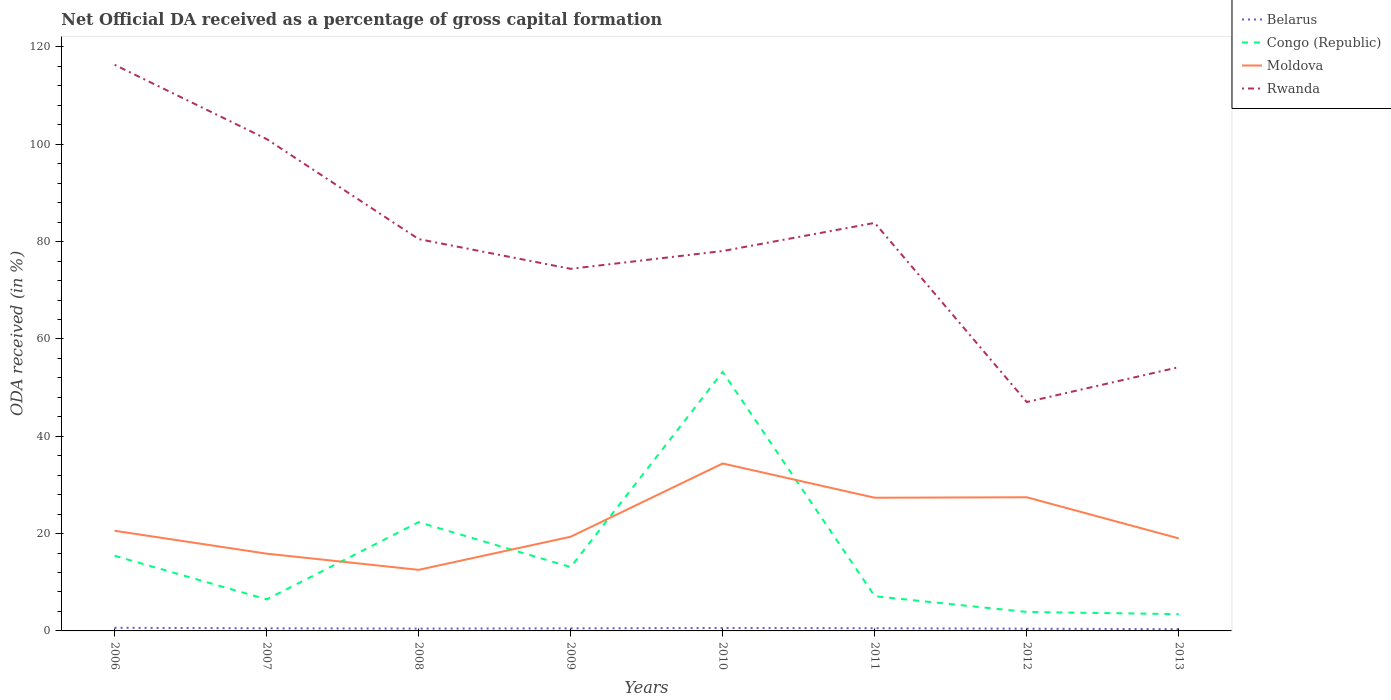How many different coloured lines are there?
Offer a very short reply. 4. Does the line corresponding to Congo (Republic) intersect with the line corresponding to Moldova?
Your answer should be compact. Yes. Across all years, what is the maximum net ODA received in Moldova?
Give a very brief answer. 12.55. In which year was the net ODA received in Congo (Republic) maximum?
Provide a succinct answer. 2013. What is the total net ODA received in Rwanda in the graph?
Ensure brevity in your answer.  38.27. What is the difference between the highest and the second highest net ODA received in Congo (Republic)?
Your response must be concise. 49.77. Is the net ODA received in Moldova strictly greater than the net ODA received in Rwanda over the years?
Your answer should be very brief. Yes. How many lines are there?
Your response must be concise. 4. How many years are there in the graph?
Ensure brevity in your answer.  8. What is the difference between two consecutive major ticks on the Y-axis?
Provide a succinct answer. 20. Does the graph contain grids?
Offer a very short reply. No. What is the title of the graph?
Give a very brief answer. Net Official DA received as a percentage of gross capital formation. What is the label or title of the X-axis?
Make the answer very short. Years. What is the label or title of the Y-axis?
Provide a succinct answer. ODA received (in %). What is the ODA received (in %) in Belarus in 2006?
Keep it short and to the point. 0.64. What is the ODA received (in %) of Congo (Republic) in 2006?
Ensure brevity in your answer.  15.44. What is the ODA received (in %) in Moldova in 2006?
Make the answer very short. 20.58. What is the ODA received (in %) of Rwanda in 2006?
Your answer should be compact. 116.34. What is the ODA received (in %) in Belarus in 2007?
Provide a succinct answer. 0.54. What is the ODA received (in %) of Congo (Republic) in 2007?
Offer a very short reply. 6.48. What is the ODA received (in %) of Moldova in 2007?
Give a very brief answer. 15.88. What is the ODA received (in %) of Rwanda in 2007?
Offer a very short reply. 101.08. What is the ODA received (in %) of Belarus in 2008?
Offer a terse response. 0.48. What is the ODA received (in %) in Congo (Republic) in 2008?
Provide a short and direct response. 22.34. What is the ODA received (in %) in Moldova in 2008?
Provide a succinct answer. 12.55. What is the ODA received (in %) in Rwanda in 2008?
Your answer should be compact. 80.52. What is the ODA received (in %) in Belarus in 2009?
Offer a very short reply. 0.53. What is the ODA received (in %) in Congo (Republic) in 2009?
Your answer should be very brief. 13.12. What is the ODA received (in %) of Moldova in 2009?
Offer a terse response. 19.36. What is the ODA received (in %) of Rwanda in 2009?
Provide a short and direct response. 74.41. What is the ODA received (in %) in Belarus in 2010?
Ensure brevity in your answer.  0.61. What is the ODA received (in %) of Congo (Republic) in 2010?
Your answer should be very brief. 53.22. What is the ODA received (in %) of Moldova in 2010?
Provide a short and direct response. 34.41. What is the ODA received (in %) of Rwanda in 2010?
Give a very brief answer. 78.07. What is the ODA received (in %) in Belarus in 2011?
Offer a very short reply. 0.56. What is the ODA received (in %) in Congo (Republic) in 2011?
Offer a very short reply. 7.13. What is the ODA received (in %) of Moldova in 2011?
Your response must be concise. 27.37. What is the ODA received (in %) in Rwanda in 2011?
Give a very brief answer. 83.84. What is the ODA received (in %) of Belarus in 2012?
Your response must be concise. 0.46. What is the ODA received (in %) in Congo (Republic) in 2012?
Your response must be concise. 3.9. What is the ODA received (in %) in Moldova in 2012?
Offer a very short reply. 27.47. What is the ODA received (in %) in Rwanda in 2012?
Provide a short and direct response. 47.03. What is the ODA received (in %) in Belarus in 2013?
Provide a succinct answer. 0.36. What is the ODA received (in %) in Congo (Republic) in 2013?
Offer a very short reply. 3.45. What is the ODA received (in %) in Moldova in 2013?
Give a very brief answer. 19.02. What is the ODA received (in %) of Rwanda in 2013?
Offer a very short reply. 54.19. Across all years, what is the maximum ODA received (in %) in Belarus?
Ensure brevity in your answer.  0.64. Across all years, what is the maximum ODA received (in %) of Congo (Republic)?
Give a very brief answer. 53.22. Across all years, what is the maximum ODA received (in %) in Moldova?
Offer a terse response. 34.41. Across all years, what is the maximum ODA received (in %) in Rwanda?
Offer a very short reply. 116.34. Across all years, what is the minimum ODA received (in %) in Belarus?
Provide a succinct answer. 0.36. Across all years, what is the minimum ODA received (in %) of Congo (Republic)?
Ensure brevity in your answer.  3.45. Across all years, what is the minimum ODA received (in %) of Moldova?
Offer a terse response. 12.55. Across all years, what is the minimum ODA received (in %) in Rwanda?
Your answer should be very brief. 47.03. What is the total ODA received (in %) in Belarus in the graph?
Your response must be concise. 4.19. What is the total ODA received (in %) in Congo (Republic) in the graph?
Ensure brevity in your answer.  125.08. What is the total ODA received (in %) in Moldova in the graph?
Provide a succinct answer. 176.63. What is the total ODA received (in %) of Rwanda in the graph?
Your answer should be compact. 635.48. What is the difference between the ODA received (in %) in Belarus in 2006 and that in 2007?
Give a very brief answer. 0.1. What is the difference between the ODA received (in %) in Congo (Republic) in 2006 and that in 2007?
Provide a short and direct response. 8.96. What is the difference between the ODA received (in %) of Moldova in 2006 and that in 2007?
Your response must be concise. 4.7. What is the difference between the ODA received (in %) in Rwanda in 2006 and that in 2007?
Provide a succinct answer. 15.26. What is the difference between the ODA received (in %) in Belarus in 2006 and that in 2008?
Give a very brief answer. 0.16. What is the difference between the ODA received (in %) of Congo (Republic) in 2006 and that in 2008?
Your answer should be very brief. -6.9. What is the difference between the ODA received (in %) in Moldova in 2006 and that in 2008?
Offer a very short reply. 8.03. What is the difference between the ODA received (in %) of Rwanda in 2006 and that in 2008?
Provide a short and direct response. 35.82. What is the difference between the ODA received (in %) in Belarus in 2006 and that in 2009?
Your answer should be very brief. 0.11. What is the difference between the ODA received (in %) of Congo (Republic) in 2006 and that in 2009?
Your answer should be compact. 2.33. What is the difference between the ODA received (in %) of Moldova in 2006 and that in 2009?
Offer a terse response. 1.23. What is the difference between the ODA received (in %) in Rwanda in 2006 and that in 2009?
Provide a succinct answer. 41.93. What is the difference between the ODA received (in %) in Belarus in 2006 and that in 2010?
Provide a succinct answer. 0.04. What is the difference between the ODA received (in %) in Congo (Republic) in 2006 and that in 2010?
Give a very brief answer. -37.77. What is the difference between the ODA received (in %) in Moldova in 2006 and that in 2010?
Your response must be concise. -13.82. What is the difference between the ODA received (in %) in Rwanda in 2006 and that in 2010?
Your answer should be very brief. 38.27. What is the difference between the ODA received (in %) of Belarus in 2006 and that in 2011?
Provide a succinct answer. 0.08. What is the difference between the ODA received (in %) in Congo (Republic) in 2006 and that in 2011?
Offer a terse response. 8.32. What is the difference between the ODA received (in %) of Moldova in 2006 and that in 2011?
Your answer should be compact. -6.79. What is the difference between the ODA received (in %) of Rwanda in 2006 and that in 2011?
Provide a short and direct response. 32.49. What is the difference between the ODA received (in %) of Belarus in 2006 and that in 2012?
Ensure brevity in your answer.  0.18. What is the difference between the ODA received (in %) in Congo (Republic) in 2006 and that in 2012?
Give a very brief answer. 11.55. What is the difference between the ODA received (in %) in Moldova in 2006 and that in 2012?
Offer a very short reply. -6.88. What is the difference between the ODA received (in %) in Rwanda in 2006 and that in 2012?
Provide a short and direct response. 69.3. What is the difference between the ODA received (in %) of Belarus in 2006 and that in 2013?
Give a very brief answer. 0.28. What is the difference between the ODA received (in %) of Congo (Republic) in 2006 and that in 2013?
Ensure brevity in your answer.  11.99. What is the difference between the ODA received (in %) of Moldova in 2006 and that in 2013?
Give a very brief answer. 1.57. What is the difference between the ODA received (in %) of Rwanda in 2006 and that in 2013?
Your answer should be very brief. 62.14. What is the difference between the ODA received (in %) of Belarus in 2007 and that in 2008?
Offer a terse response. 0.06. What is the difference between the ODA received (in %) in Congo (Republic) in 2007 and that in 2008?
Your answer should be very brief. -15.86. What is the difference between the ODA received (in %) in Moldova in 2007 and that in 2008?
Your answer should be compact. 3.32. What is the difference between the ODA received (in %) in Rwanda in 2007 and that in 2008?
Give a very brief answer. 20.56. What is the difference between the ODA received (in %) of Belarus in 2007 and that in 2009?
Your answer should be compact. 0.01. What is the difference between the ODA received (in %) in Congo (Republic) in 2007 and that in 2009?
Your answer should be compact. -6.63. What is the difference between the ODA received (in %) in Moldova in 2007 and that in 2009?
Your response must be concise. -3.48. What is the difference between the ODA received (in %) of Rwanda in 2007 and that in 2009?
Give a very brief answer. 26.67. What is the difference between the ODA received (in %) of Belarus in 2007 and that in 2010?
Keep it short and to the point. -0.06. What is the difference between the ODA received (in %) in Congo (Republic) in 2007 and that in 2010?
Offer a terse response. -46.73. What is the difference between the ODA received (in %) in Moldova in 2007 and that in 2010?
Keep it short and to the point. -18.53. What is the difference between the ODA received (in %) in Rwanda in 2007 and that in 2010?
Your response must be concise. 23.01. What is the difference between the ODA received (in %) of Belarus in 2007 and that in 2011?
Give a very brief answer. -0.02. What is the difference between the ODA received (in %) in Congo (Republic) in 2007 and that in 2011?
Your answer should be compact. -0.64. What is the difference between the ODA received (in %) in Moldova in 2007 and that in 2011?
Ensure brevity in your answer.  -11.49. What is the difference between the ODA received (in %) of Rwanda in 2007 and that in 2011?
Offer a terse response. 17.23. What is the difference between the ODA received (in %) of Belarus in 2007 and that in 2012?
Provide a short and direct response. 0.08. What is the difference between the ODA received (in %) in Congo (Republic) in 2007 and that in 2012?
Your response must be concise. 2.59. What is the difference between the ODA received (in %) of Moldova in 2007 and that in 2012?
Provide a short and direct response. -11.59. What is the difference between the ODA received (in %) in Rwanda in 2007 and that in 2012?
Make the answer very short. 54.04. What is the difference between the ODA received (in %) of Belarus in 2007 and that in 2013?
Ensure brevity in your answer.  0.18. What is the difference between the ODA received (in %) of Congo (Republic) in 2007 and that in 2013?
Offer a very short reply. 3.03. What is the difference between the ODA received (in %) of Moldova in 2007 and that in 2013?
Offer a very short reply. -3.14. What is the difference between the ODA received (in %) of Rwanda in 2007 and that in 2013?
Offer a very short reply. 46.88. What is the difference between the ODA received (in %) in Belarus in 2008 and that in 2009?
Your answer should be compact. -0.05. What is the difference between the ODA received (in %) of Congo (Republic) in 2008 and that in 2009?
Provide a succinct answer. 9.23. What is the difference between the ODA received (in %) of Moldova in 2008 and that in 2009?
Make the answer very short. -6.8. What is the difference between the ODA received (in %) of Rwanda in 2008 and that in 2009?
Provide a short and direct response. 6.11. What is the difference between the ODA received (in %) of Belarus in 2008 and that in 2010?
Your response must be concise. -0.12. What is the difference between the ODA received (in %) of Congo (Republic) in 2008 and that in 2010?
Provide a short and direct response. -30.87. What is the difference between the ODA received (in %) in Moldova in 2008 and that in 2010?
Your response must be concise. -21.85. What is the difference between the ODA received (in %) in Rwanda in 2008 and that in 2010?
Your answer should be very brief. 2.45. What is the difference between the ODA received (in %) in Belarus in 2008 and that in 2011?
Offer a terse response. -0.08. What is the difference between the ODA received (in %) of Congo (Republic) in 2008 and that in 2011?
Your response must be concise. 15.22. What is the difference between the ODA received (in %) of Moldova in 2008 and that in 2011?
Your response must be concise. -14.82. What is the difference between the ODA received (in %) in Rwanda in 2008 and that in 2011?
Make the answer very short. -3.33. What is the difference between the ODA received (in %) of Belarus in 2008 and that in 2012?
Your answer should be very brief. 0.02. What is the difference between the ODA received (in %) in Congo (Republic) in 2008 and that in 2012?
Keep it short and to the point. 18.45. What is the difference between the ODA received (in %) in Moldova in 2008 and that in 2012?
Your response must be concise. -14.91. What is the difference between the ODA received (in %) of Rwanda in 2008 and that in 2012?
Keep it short and to the point. 33.48. What is the difference between the ODA received (in %) in Belarus in 2008 and that in 2013?
Your answer should be compact. 0.12. What is the difference between the ODA received (in %) in Congo (Republic) in 2008 and that in 2013?
Ensure brevity in your answer.  18.89. What is the difference between the ODA received (in %) of Moldova in 2008 and that in 2013?
Provide a short and direct response. -6.46. What is the difference between the ODA received (in %) of Rwanda in 2008 and that in 2013?
Ensure brevity in your answer.  26.33. What is the difference between the ODA received (in %) of Belarus in 2009 and that in 2010?
Give a very brief answer. -0.07. What is the difference between the ODA received (in %) of Congo (Republic) in 2009 and that in 2010?
Provide a succinct answer. -40.1. What is the difference between the ODA received (in %) in Moldova in 2009 and that in 2010?
Offer a very short reply. -15.05. What is the difference between the ODA received (in %) in Rwanda in 2009 and that in 2010?
Ensure brevity in your answer.  -3.66. What is the difference between the ODA received (in %) of Belarus in 2009 and that in 2011?
Keep it short and to the point. -0.03. What is the difference between the ODA received (in %) in Congo (Republic) in 2009 and that in 2011?
Offer a terse response. 5.99. What is the difference between the ODA received (in %) in Moldova in 2009 and that in 2011?
Your answer should be compact. -8.02. What is the difference between the ODA received (in %) in Rwanda in 2009 and that in 2011?
Offer a terse response. -9.43. What is the difference between the ODA received (in %) in Belarus in 2009 and that in 2012?
Provide a short and direct response. 0.07. What is the difference between the ODA received (in %) in Congo (Republic) in 2009 and that in 2012?
Keep it short and to the point. 9.22. What is the difference between the ODA received (in %) in Moldova in 2009 and that in 2012?
Provide a succinct answer. -8.11. What is the difference between the ODA received (in %) of Rwanda in 2009 and that in 2012?
Your answer should be compact. 27.38. What is the difference between the ODA received (in %) of Belarus in 2009 and that in 2013?
Your answer should be compact. 0.17. What is the difference between the ODA received (in %) in Congo (Republic) in 2009 and that in 2013?
Your response must be concise. 9.67. What is the difference between the ODA received (in %) of Moldova in 2009 and that in 2013?
Offer a very short reply. 0.34. What is the difference between the ODA received (in %) of Rwanda in 2009 and that in 2013?
Provide a succinct answer. 20.22. What is the difference between the ODA received (in %) in Belarus in 2010 and that in 2011?
Give a very brief answer. 0.05. What is the difference between the ODA received (in %) in Congo (Republic) in 2010 and that in 2011?
Keep it short and to the point. 46.09. What is the difference between the ODA received (in %) of Moldova in 2010 and that in 2011?
Ensure brevity in your answer.  7.04. What is the difference between the ODA received (in %) in Rwanda in 2010 and that in 2011?
Offer a very short reply. -5.78. What is the difference between the ODA received (in %) of Belarus in 2010 and that in 2012?
Make the answer very short. 0.15. What is the difference between the ODA received (in %) of Congo (Republic) in 2010 and that in 2012?
Provide a short and direct response. 49.32. What is the difference between the ODA received (in %) of Moldova in 2010 and that in 2012?
Your answer should be compact. 6.94. What is the difference between the ODA received (in %) in Rwanda in 2010 and that in 2012?
Offer a very short reply. 31.03. What is the difference between the ODA received (in %) in Belarus in 2010 and that in 2013?
Keep it short and to the point. 0.24. What is the difference between the ODA received (in %) in Congo (Republic) in 2010 and that in 2013?
Your response must be concise. 49.77. What is the difference between the ODA received (in %) in Moldova in 2010 and that in 2013?
Offer a very short reply. 15.39. What is the difference between the ODA received (in %) of Rwanda in 2010 and that in 2013?
Ensure brevity in your answer.  23.88. What is the difference between the ODA received (in %) of Belarus in 2011 and that in 2012?
Give a very brief answer. 0.1. What is the difference between the ODA received (in %) of Congo (Republic) in 2011 and that in 2012?
Give a very brief answer. 3.23. What is the difference between the ODA received (in %) in Moldova in 2011 and that in 2012?
Keep it short and to the point. -0.1. What is the difference between the ODA received (in %) of Rwanda in 2011 and that in 2012?
Give a very brief answer. 36.81. What is the difference between the ODA received (in %) in Belarus in 2011 and that in 2013?
Provide a succinct answer. 0.2. What is the difference between the ODA received (in %) of Congo (Republic) in 2011 and that in 2013?
Offer a very short reply. 3.67. What is the difference between the ODA received (in %) of Moldova in 2011 and that in 2013?
Your response must be concise. 8.35. What is the difference between the ODA received (in %) in Rwanda in 2011 and that in 2013?
Offer a very short reply. 29.65. What is the difference between the ODA received (in %) in Belarus in 2012 and that in 2013?
Your answer should be very brief. 0.09. What is the difference between the ODA received (in %) in Congo (Republic) in 2012 and that in 2013?
Provide a short and direct response. 0.45. What is the difference between the ODA received (in %) in Moldova in 2012 and that in 2013?
Your response must be concise. 8.45. What is the difference between the ODA received (in %) in Rwanda in 2012 and that in 2013?
Give a very brief answer. -7.16. What is the difference between the ODA received (in %) of Belarus in 2006 and the ODA received (in %) of Congo (Republic) in 2007?
Ensure brevity in your answer.  -5.84. What is the difference between the ODA received (in %) in Belarus in 2006 and the ODA received (in %) in Moldova in 2007?
Make the answer very short. -15.23. What is the difference between the ODA received (in %) of Belarus in 2006 and the ODA received (in %) of Rwanda in 2007?
Keep it short and to the point. -100.43. What is the difference between the ODA received (in %) of Congo (Republic) in 2006 and the ODA received (in %) of Moldova in 2007?
Your answer should be compact. -0.43. What is the difference between the ODA received (in %) of Congo (Republic) in 2006 and the ODA received (in %) of Rwanda in 2007?
Give a very brief answer. -85.63. What is the difference between the ODA received (in %) of Moldova in 2006 and the ODA received (in %) of Rwanda in 2007?
Keep it short and to the point. -80.49. What is the difference between the ODA received (in %) of Belarus in 2006 and the ODA received (in %) of Congo (Republic) in 2008?
Your answer should be compact. -21.7. What is the difference between the ODA received (in %) in Belarus in 2006 and the ODA received (in %) in Moldova in 2008?
Give a very brief answer. -11.91. What is the difference between the ODA received (in %) of Belarus in 2006 and the ODA received (in %) of Rwanda in 2008?
Provide a succinct answer. -79.88. What is the difference between the ODA received (in %) of Congo (Republic) in 2006 and the ODA received (in %) of Moldova in 2008?
Make the answer very short. 2.89. What is the difference between the ODA received (in %) of Congo (Republic) in 2006 and the ODA received (in %) of Rwanda in 2008?
Give a very brief answer. -65.07. What is the difference between the ODA received (in %) of Moldova in 2006 and the ODA received (in %) of Rwanda in 2008?
Provide a short and direct response. -59.94. What is the difference between the ODA received (in %) of Belarus in 2006 and the ODA received (in %) of Congo (Republic) in 2009?
Offer a terse response. -12.47. What is the difference between the ODA received (in %) of Belarus in 2006 and the ODA received (in %) of Moldova in 2009?
Offer a very short reply. -18.71. What is the difference between the ODA received (in %) in Belarus in 2006 and the ODA received (in %) in Rwanda in 2009?
Provide a short and direct response. -73.77. What is the difference between the ODA received (in %) in Congo (Republic) in 2006 and the ODA received (in %) in Moldova in 2009?
Give a very brief answer. -3.91. What is the difference between the ODA received (in %) of Congo (Republic) in 2006 and the ODA received (in %) of Rwanda in 2009?
Ensure brevity in your answer.  -58.97. What is the difference between the ODA received (in %) in Moldova in 2006 and the ODA received (in %) in Rwanda in 2009?
Make the answer very short. -53.83. What is the difference between the ODA received (in %) in Belarus in 2006 and the ODA received (in %) in Congo (Republic) in 2010?
Provide a succinct answer. -52.57. What is the difference between the ODA received (in %) in Belarus in 2006 and the ODA received (in %) in Moldova in 2010?
Your answer should be very brief. -33.76. What is the difference between the ODA received (in %) of Belarus in 2006 and the ODA received (in %) of Rwanda in 2010?
Ensure brevity in your answer.  -77.43. What is the difference between the ODA received (in %) in Congo (Republic) in 2006 and the ODA received (in %) in Moldova in 2010?
Your answer should be compact. -18.96. What is the difference between the ODA received (in %) in Congo (Republic) in 2006 and the ODA received (in %) in Rwanda in 2010?
Provide a short and direct response. -62.62. What is the difference between the ODA received (in %) of Moldova in 2006 and the ODA received (in %) of Rwanda in 2010?
Provide a succinct answer. -57.49. What is the difference between the ODA received (in %) in Belarus in 2006 and the ODA received (in %) in Congo (Republic) in 2011?
Give a very brief answer. -6.48. What is the difference between the ODA received (in %) of Belarus in 2006 and the ODA received (in %) of Moldova in 2011?
Provide a short and direct response. -26.73. What is the difference between the ODA received (in %) in Belarus in 2006 and the ODA received (in %) in Rwanda in 2011?
Ensure brevity in your answer.  -83.2. What is the difference between the ODA received (in %) of Congo (Republic) in 2006 and the ODA received (in %) of Moldova in 2011?
Your answer should be very brief. -11.93. What is the difference between the ODA received (in %) of Congo (Republic) in 2006 and the ODA received (in %) of Rwanda in 2011?
Your response must be concise. -68.4. What is the difference between the ODA received (in %) of Moldova in 2006 and the ODA received (in %) of Rwanda in 2011?
Your response must be concise. -63.26. What is the difference between the ODA received (in %) of Belarus in 2006 and the ODA received (in %) of Congo (Republic) in 2012?
Give a very brief answer. -3.25. What is the difference between the ODA received (in %) in Belarus in 2006 and the ODA received (in %) in Moldova in 2012?
Ensure brevity in your answer.  -26.82. What is the difference between the ODA received (in %) in Belarus in 2006 and the ODA received (in %) in Rwanda in 2012?
Offer a very short reply. -46.39. What is the difference between the ODA received (in %) in Congo (Republic) in 2006 and the ODA received (in %) in Moldova in 2012?
Keep it short and to the point. -12.02. What is the difference between the ODA received (in %) in Congo (Republic) in 2006 and the ODA received (in %) in Rwanda in 2012?
Ensure brevity in your answer.  -31.59. What is the difference between the ODA received (in %) in Moldova in 2006 and the ODA received (in %) in Rwanda in 2012?
Offer a terse response. -26.45. What is the difference between the ODA received (in %) in Belarus in 2006 and the ODA received (in %) in Congo (Republic) in 2013?
Your answer should be compact. -2.81. What is the difference between the ODA received (in %) of Belarus in 2006 and the ODA received (in %) of Moldova in 2013?
Make the answer very short. -18.37. What is the difference between the ODA received (in %) of Belarus in 2006 and the ODA received (in %) of Rwanda in 2013?
Ensure brevity in your answer.  -53.55. What is the difference between the ODA received (in %) in Congo (Republic) in 2006 and the ODA received (in %) in Moldova in 2013?
Your answer should be compact. -3.57. What is the difference between the ODA received (in %) in Congo (Republic) in 2006 and the ODA received (in %) in Rwanda in 2013?
Your answer should be compact. -38.75. What is the difference between the ODA received (in %) in Moldova in 2006 and the ODA received (in %) in Rwanda in 2013?
Provide a succinct answer. -33.61. What is the difference between the ODA received (in %) of Belarus in 2007 and the ODA received (in %) of Congo (Republic) in 2008?
Your answer should be compact. -21.8. What is the difference between the ODA received (in %) of Belarus in 2007 and the ODA received (in %) of Moldova in 2008?
Provide a succinct answer. -12.01. What is the difference between the ODA received (in %) of Belarus in 2007 and the ODA received (in %) of Rwanda in 2008?
Make the answer very short. -79.98. What is the difference between the ODA received (in %) of Congo (Republic) in 2007 and the ODA received (in %) of Moldova in 2008?
Provide a short and direct response. -6.07. What is the difference between the ODA received (in %) in Congo (Republic) in 2007 and the ODA received (in %) in Rwanda in 2008?
Give a very brief answer. -74.04. What is the difference between the ODA received (in %) in Moldova in 2007 and the ODA received (in %) in Rwanda in 2008?
Provide a short and direct response. -64.64. What is the difference between the ODA received (in %) in Belarus in 2007 and the ODA received (in %) in Congo (Republic) in 2009?
Keep it short and to the point. -12.57. What is the difference between the ODA received (in %) in Belarus in 2007 and the ODA received (in %) in Moldova in 2009?
Make the answer very short. -18.81. What is the difference between the ODA received (in %) of Belarus in 2007 and the ODA received (in %) of Rwanda in 2009?
Give a very brief answer. -73.87. What is the difference between the ODA received (in %) in Congo (Republic) in 2007 and the ODA received (in %) in Moldova in 2009?
Your answer should be very brief. -12.87. What is the difference between the ODA received (in %) of Congo (Republic) in 2007 and the ODA received (in %) of Rwanda in 2009?
Give a very brief answer. -67.93. What is the difference between the ODA received (in %) of Moldova in 2007 and the ODA received (in %) of Rwanda in 2009?
Offer a very short reply. -58.53. What is the difference between the ODA received (in %) in Belarus in 2007 and the ODA received (in %) in Congo (Republic) in 2010?
Give a very brief answer. -52.68. What is the difference between the ODA received (in %) in Belarus in 2007 and the ODA received (in %) in Moldova in 2010?
Ensure brevity in your answer.  -33.86. What is the difference between the ODA received (in %) of Belarus in 2007 and the ODA received (in %) of Rwanda in 2010?
Keep it short and to the point. -77.53. What is the difference between the ODA received (in %) of Congo (Republic) in 2007 and the ODA received (in %) of Moldova in 2010?
Provide a succinct answer. -27.92. What is the difference between the ODA received (in %) of Congo (Republic) in 2007 and the ODA received (in %) of Rwanda in 2010?
Your response must be concise. -71.59. What is the difference between the ODA received (in %) of Moldova in 2007 and the ODA received (in %) of Rwanda in 2010?
Your response must be concise. -62.19. What is the difference between the ODA received (in %) of Belarus in 2007 and the ODA received (in %) of Congo (Republic) in 2011?
Ensure brevity in your answer.  -6.58. What is the difference between the ODA received (in %) in Belarus in 2007 and the ODA received (in %) in Moldova in 2011?
Your answer should be very brief. -26.83. What is the difference between the ODA received (in %) of Belarus in 2007 and the ODA received (in %) of Rwanda in 2011?
Offer a terse response. -83.3. What is the difference between the ODA received (in %) of Congo (Republic) in 2007 and the ODA received (in %) of Moldova in 2011?
Your response must be concise. -20.89. What is the difference between the ODA received (in %) in Congo (Republic) in 2007 and the ODA received (in %) in Rwanda in 2011?
Provide a succinct answer. -77.36. What is the difference between the ODA received (in %) in Moldova in 2007 and the ODA received (in %) in Rwanda in 2011?
Keep it short and to the point. -67.97. What is the difference between the ODA received (in %) of Belarus in 2007 and the ODA received (in %) of Congo (Republic) in 2012?
Your response must be concise. -3.36. What is the difference between the ODA received (in %) of Belarus in 2007 and the ODA received (in %) of Moldova in 2012?
Provide a short and direct response. -26.92. What is the difference between the ODA received (in %) in Belarus in 2007 and the ODA received (in %) in Rwanda in 2012?
Offer a very short reply. -46.49. What is the difference between the ODA received (in %) in Congo (Republic) in 2007 and the ODA received (in %) in Moldova in 2012?
Offer a terse response. -20.98. What is the difference between the ODA received (in %) of Congo (Republic) in 2007 and the ODA received (in %) of Rwanda in 2012?
Make the answer very short. -40.55. What is the difference between the ODA received (in %) of Moldova in 2007 and the ODA received (in %) of Rwanda in 2012?
Your answer should be compact. -31.16. What is the difference between the ODA received (in %) in Belarus in 2007 and the ODA received (in %) in Congo (Republic) in 2013?
Your response must be concise. -2.91. What is the difference between the ODA received (in %) of Belarus in 2007 and the ODA received (in %) of Moldova in 2013?
Offer a very short reply. -18.47. What is the difference between the ODA received (in %) in Belarus in 2007 and the ODA received (in %) in Rwanda in 2013?
Provide a succinct answer. -53.65. What is the difference between the ODA received (in %) of Congo (Republic) in 2007 and the ODA received (in %) of Moldova in 2013?
Your answer should be compact. -12.53. What is the difference between the ODA received (in %) in Congo (Republic) in 2007 and the ODA received (in %) in Rwanda in 2013?
Offer a terse response. -47.71. What is the difference between the ODA received (in %) of Moldova in 2007 and the ODA received (in %) of Rwanda in 2013?
Your answer should be compact. -38.31. What is the difference between the ODA received (in %) of Belarus in 2008 and the ODA received (in %) of Congo (Republic) in 2009?
Make the answer very short. -12.63. What is the difference between the ODA received (in %) of Belarus in 2008 and the ODA received (in %) of Moldova in 2009?
Provide a short and direct response. -18.87. What is the difference between the ODA received (in %) of Belarus in 2008 and the ODA received (in %) of Rwanda in 2009?
Your answer should be compact. -73.93. What is the difference between the ODA received (in %) of Congo (Republic) in 2008 and the ODA received (in %) of Moldova in 2009?
Offer a very short reply. 2.99. What is the difference between the ODA received (in %) of Congo (Republic) in 2008 and the ODA received (in %) of Rwanda in 2009?
Your answer should be compact. -52.07. What is the difference between the ODA received (in %) in Moldova in 2008 and the ODA received (in %) in Rwanda in 2009?
Ensure brevity in your answer.  -61.86. What is the difference between the ODA received (in %) in Belarus in 2008 and the ODA received (in %) in Congo (Republic) in 2010?
Ensure brevity in your answer.  -52.73. What is the difference between the ODA received (in %) of Belarus in 2008 and the ODA received (in %) of Moldova in 2010?
Your answer should be compact. -33.92. What is the difference between the ODA received (in %) of Belarus in 2008 and the ODA received (in %) of Rwanda in 2010?
Provide a short and direct response. -77.59. What is the difference between the ODA received (in %) in Congo (Republic) in 2008 and the ODA received (in %) in Moldova in 2010?
Your response must be concise. -12.06. What is the difference between the ODA received (in %) in Congo (Republic) in 2008 and the ODA received (in %) in Rwanda in 2010?
Provide a short and direct response. -55.72. What is the difference between the ODA received (in %) of Moldova in 2008 and the ODA received (in %) of Rwanda in 2010?
Give a very brief answer. -65.51. What is the difference between the ODA received (in %) of Belarus in 2008 and the ODA received (in %) of Congo (Republic) in 2011?
Make the answer very short. -6.64. What is the difference between the ODA received (in %) in Belarus in 2008 and the ODA received (in %) in Moldova in 2011?
Make the answer very short. -26.89. What is the difference between the ODA received (in %) of Belarus in 2008 and the ODA received (in %) of Rwanda in 2011?
Your answer should be very brief. -83.36. What is the difference between the ODA received (in %) of Congo (Republic) in 2008 and the ODA received (in %) of Moldova in 2011?
Provide a short and direct response. -5.03. What is the difference between the ODA received (in %) in Congo (Republic) in 2008 and the ODA received (in %) in Rwanda in 2011?
Your answer should be compact. -61.5. What is the difference between the ODA received (in %) in Moldova in 2008 and the ODA received (in %) in Rwanda in 2011?
Keep it short and to the point. -71.29. What is the difference between the ODA received (in %) of Belarus in 2008 and the ODA received (in %) of Congo (Republic) in 2012?
Provide a short and direct response. -3.42. What is the difference between the ODA received (in %) in Belarus in 2008 and the ODA received (in %) in Moldova in 2012?
Your answer should be compact. -26.98. What is the difference between the ODA received (in %) in Belarus in 2008 and the ODA received (in %) in Rwanda in 2012?
Give a very brief answer. -46.55. What is the difference between the ODA received (in %) of Congo (Republic) in 2008 and the ODA received (in %) of Moldova in 2012?
Provide a short and direct response. -5.12. What is the difference between the ODA received (in %) in Congo (Republic) in 2008 and the ODA received (in %) in Rwanda in 2012?
Provide a succinct answer. -24.69. What is the difference between the ODA received (in %) in Moldova in 2008 and the ODA received (in %) in Rwanda in 2012?
Provide a short and direct response. -34.48. What is the difference between the ODA received (in %) in Belarus in 2008 and the ODA received (in %) in Congo (Republic) in 2013?
Offer a terse response. -2.97. What is the difference between the ODA received (in %) of Belarus in 2008 and the ODA received (in %) of Moldova in 2013?
Provide a succinct answer. -18.53. What is the difference between the ODA received (in %) in Belarus in 2008 and the ODA received (in %) in Rwanda in 2013?
Offer a terse response. -53.71. What is the difference between the ODA received (in %) in Congo (Republic) in 2008 and the ODA received (in %) in Moldova in 2013?
Keep it short and to the point. 3.33. What is the difference between the ODA received (in %) in Congo (Republic) in 2008 and the ODA received (in %) in Rwanda in 2013?
Provide a short and direct response. -31.85. What is the difference between the ODA received (in %) in Moldova in 2008 and the ODA received (in %) in Rwanda in 2013?
Your answer should be very brief. -41.64. What is the difference between the ODA received (in %) in Belarus in 2009 and the ODA received (in %) in Congo (Republic) in 2010?
Your response must be concise. -52.69. What is the difference between the ODA received (in %) in Belarus in 2009 and the ODA received (in %) in Moldova in 2010?
Give a very brief answer. -33.88. What is the difference between the ODA received (in %) of Belarus in 2009 and the ODA received (in %) of Rwanda in 2010?
Make the answer very short. -77.54. What is the difference between the ODA received (in %) in Congo (Republic) in 2009 and the ODA received (in %) in Moldova in 2010?
Keep it short and to the point. -21.29. What is the difference between the ODA received (in %) of Congo (Republic) in 2009 and the ODA received (in %) of Rwanda in 2010?
Make the answer very short. -64.95. What is the difference between the ODA received (in %) in Moldova in 2009 and the ODA received (in %) in Rwanda in 2010?
Ensure brevity in your answer.  -58.71. What is the difference between the ODA received (in %) in Belarus in 2009 and the ODA received (in %) in Congo (Republic) in 2011?
Provide a succinct answer. -6.59. What is the difference between the ODA received (in %) in Belarus in 2009 and the ODA received (in %) in Moldova in 2011?
Your answer should be compact. -26.84. What is the difference between the ODA received (in %) of Belarus in 2009 and the ODA received (in %) of Rwanda in 2011?
Your answer should be compact. -83.31. What is the difference between the ODA received (in %) in Congo (Republic) in 2009 and the ODA received (in %) in Moldova in 2011?
Your response must be concise. -14.25. What is the difference between the ODA received (in %) in Congo (Republic) in 2009 and the ODA received (in %) in Rwanda in 2011?
Keep it short and to the point. -70.73. What is the difference between the ODA received (in %) of Moldova in 2009 and the ODA received (in %) of Rwanda in 2011?
Provide a succinct answer. -64.49. What is the difference between the ODA received (in %) of Belarus in 2009 and the ODA received (in %) of Congo (Republic) in 2012?
Your answer should be very brief. -3.37. What is the difference between the ODA received (in %) of Belarus in 2009 and the ODA received (in %) of Moldova in 2012?
Keep it short and to the point. -26.93. What is the difference between the ODA received (in %) of Belarus in 2009 and the ODA received (in %) of Rwanda in 2012?
Your answer should be compact. -46.5. What is the difference between the ODA received (in %) of Congo (Republic) in 2009 and the ODA received (in %) of Moldova in 2012?
Your answer should be very brief. -14.35. What is the difference between the ODA received (in %) of Congo (Republic) in 2009 and the ODA received (in %) of Rwanda in 2012?
Provide a succinct answer. -33.92. What is the difference between the ODA received (in %) of Moldova in 2009 and the ODA received (in %) of Rwanda in 2012?
Your response must be concise. -27.68. What is the difference between the ODA received (in %) of Belarus in 2009 and the ODA received (in %) of Congo (Republic) in 2013?
Make the answer very short. -2.92. What is the difference between the ODA received (in %) in Belarus in 2009 and the ODA received (in %) in Moldova in 2013?
Offer a very short reply. -18.48. What is the difference between the ODA received (in %) in Belarus in 2009 and the ODA received (in %) in Rwanda in 2013?
Provide a short and direct response. -53.66. What is the difference between the ODA received (in %) in Congo (Republic) in 2009 and the ODA received (in %) in Moldova in 2013?
Provide a short and direct response. -5.9. What is the difference between the ODA received (in %) of Congo (Republic) in 2009 and the ODA received (in %) of Rwanda in 2013?
Make the answer very short. -41.08. What is the difference between the ODA received (in %) of Moldova in 2009 and the ODA received (in %) of Rwanda in 2013?
Offer a terse response. -34.84. What is the difference between the ODA received (in %) in Belarus in 2010 and the ODA received (in %) in Congo (Republic) in 2011?
Make the answer very short. -6.52. What is the difference between the ODA received (in %) in Belarus in 2010 and the ODA received (in %) in Moldova in 2011?
Keep it short and to the point. -26.76. What is the difference between the ODA received (in %) in Belarus in 2010 and the ODA received (in %) in Rwanda in 2011?
Provide a short and direct response. -83.24. What is the difference between the ODA received (in %) of Congo (Republic) in 2010 and the ODA received (in %) of Moldova in 2011?
Provide a short and direct response. 25.85. What is the difference between the ODA received (in %) of Congo (Republic) in 2010 and the ODA received (in %) of Rwanda in 2011?
Make the answer very short. -30.63. What is the difference between the ODA received (in %) in Moldova in 2010 and the ODA received (in %) in Rwanda in 2011?
Your response must be concise. -49.44. What is the difference between the ODA received (in %) in Belarus in 2010 and the ODA received (in %) in Congo (Republic) in 2012?
Give a very brief answer. -3.29. What is the difference between the ODA received (in %) of Belarus in 2010 and the ODA received (in %) of Moldova in 2012?
Your answer should be very brief. -26.86. What is the difference between the ODA received (in %) in Belarus in 2010 and the ODA received (in %) in Rwanda in 2012?
Your response must be concise. -46.43. What is the difference between the ODA received (in %) of Congo (Republic) in 2010 and the ODA received (in %) of Moldova in 2012?
Your response must be concise. 25.75. What is the difference between the ODA received (in %) of Congo (Republic) in 2010 and the ODA received (in %) of Rwanda in 2012?
Provide a succinct answer. 6.18. What is the difference between the ODA received (in %) of Moldova in 2010 and the ODA received (in %) of Rwanda in 2012?
Your response must be concise. -12.63. What is the difference between the ODA received (in %) in Belarus in 2010 and the ODA received (in %) in Congo (Republic) in 2013?
Provide a short and direct response. -2.84. What is the difference between the ODA received (in %) of Belarus in 2010 and the ODA received (in %) of Moldova in 2013?
Keep it short and to the point. -18.41. What is the difference between the ODA received (in %) of Belarus in 2010 and the ODA received (in %) of Rwanda in 2013?
Provide a short and direct response. -53.59. What is the difference between the ODA received (in %) in Congo (Republic) in 2010 and the ODA received (in %) in Moldova in 2013?
Provide a short and direct response. 34.2. What is the difference between the ODA received (in %) of Congo (Republic) in 2010 and the ODA received (in %) of Rwanda in 2013?
Provide a short and direct response. -0.97. What is the difference between the ODA received (in %) of Moldova in 2010 and the ODA received (in %) of Rwanda in 2013?
Your response must be concise. -19.79. What is the difference between the ODA received (in %) in Belarus in 2011 and the ODA received (in %) in Congo (Republic) in 2012?
Offer a terse response. -3.34. What is the difference between the ODA received (in %) of Belarus in 2011 and the ODA received (in %) of Moldova in 2012?
Offer a very short reply. -26.91. What is the difference between the ODA received (in %) in Belarus in 2011 and the ODA received (in %) in Rwanda in 2012?
Provide a succinct answer. -46.47. What is the difference between the ODA received (in %) in Congo (Republic) in 2011 and the ODA received (in %) in Moldova in 2012?
Your answer should be compact. -20.34. What is the difference between the ODA received (in %) of Congo (Republic) in 2011 and the ODA received (in %) of Rwanda in 2012?
Your answer should be compact. -39.91. What is the difference between the ODA received (in %) of Moldova in 2011 and the ODA received (in %) of Rwanda in 2012?
Your answer should be compact. -19.66. What is the difference between the ODA received (in %) in Belarus in 2011 and the ODA received (in %) in Congo (Republic) in 2013?
Offer a very short reply. -2.89. What is the difference between the ODA received (in %) in Belarus in 2011 and the ODA received (in %) in Moldova in 2013?
Ensure brevity in your answer.  -18.46. What is the difference between the ODA received (in %) of Belarus in 2011 and the ODA received (in %) of Rwanda in 2013?
Offer a terse response. -53.63. What is the difference between the ODA received (in %) in Congo (Republic) in 2011 and the ODA received (in %) in Moldova in 2013?
Your answer should be very brief. -11.89. What is the difference between the ODA received (in %) in Congo (Republic) in 2011 and the ODA received (in %) in Rwanda in 2013?
Give a very brief answer. -47.07. What is the difference between the ODA received (in %) in Moldova in 2011 and the ODA received (in %) in Rwanda in 2013?
Give a very brief answer. -26.82. What is the difference between the ODA received (in %) in Belarus in 2012 and the ODA received (in %) in Congo (Republic) in 2013?
Offer a terse response. -2.99. What is the difference between the ODA received (in %) in Belarus in 2012 and the ODA received (in %) in Moldova in 2013?
Your response must be concise. -18.56. What is the difference between the ODA received (in %) in Belarus in 2012 and the ODA received (in %) in Rwanda in 2013?
Make the answer very short. -53.73. What is the difference between the ODA received (in %) of Congo (Republic) in 2012 and the ODA received (in %) of Moldova in 2013?
Provide a succinct answer. -15.12. What is the difference between the ODA received (in %) in Congo (Republic) in 2012 and the ODA received (in %) in Rwanda in 2013?
Your answer should be very brief. -50.29. What is the difference between the ODA received (in %) of Moldova in 2012 and the ODA received (in %) of Rwanda in 2013?
Keep it short and to the point. -26.73. What is the average ODA received (in %) of Belarus per year?
Give a very brief answer. 0.52. What is the average ODA received (in %) of Congo (Republic) per year?
Give a very brief answer. 15.64. What is the average ODA received (in %) in Moldova per year?
Make the answer very short. 22.08. What is the average ODA received (in %) of Rwanda per year?
Provide a succinct answer. 79.44. In the year 2006, what is the difference between the ODA received (in %) of Belarus and ODA received (in %) of Congo (Republic)?
Give a very brief answer. -14.8. In the year 2006, what is the difference between the ODA received (in %) of Belarus and ODA received (in %) of Moldova?
Provide a short and direct response. -19.94. In the year 2006, what is the difference between the ODA received (in %) in Belarus and ODA received (in %) in Rwanda?
Your answer should be compact. -115.69. In the year 2006, what is the difference between the ODA received (in %) of Congo (Republic) and ODA received (in %) of Moldova?
Offer a terse response. -5.14. In the year 2006, what is the difference between the ODA received (in %) of Congo (Republic) and ODA received (in %) of Rwanda?
Your answer should be very brief. -100.89. In the year 2006, what is the difference between the ODA received (in %) of Moldova and ODA received (in %) of Rwanda?
Offer a very short reply. -95.75. In the year 2007, what is the difference between the ODA received (in %) in Belarus and ODA received (in %) in Congo (Republic)?
Keep it short and to the point. -5.94. In the year 2007, what is the difference between the ODA received (in %) in Belarus and ODA received (in %) in Moldova?
Offer a terse response. -15.34. In the year 2007, what is the difference between the ODA received (in %) in Belarus and ODA received (in %) in Rwanda?
Offer a terse response. -100.53. In the year 2007, what is the difference between the ODA received (in %) in Congo (Republic) and ODA received (in %) in Moldova?
Your response must be concise. -9.39. In the year 2007, what is the difference between the ODA received (in %) of Congo (Republic) and ODA received (in %) of Rwanda?
Provide a short and direct response. -94.59. In the year 2007, what is the difference between the ODA received (in %) in Moldova and ODA received (in %) in Rwanda?
Your answer should be compact. -85.2. In the year 2008, what is the difference between the ODA received (in %) in Belarus and ODA received (in %) in Congo (Republic)?
Your answer should be compact. -21.86. In the year 2008, what is the difference between the ODA received (in %) in Belarus and ODA received (in %) in Moldova?
Keep it short and to the point. -12.07. In the year 2008, what is the difference between the ODA received (in %) in Belarus and ODA received (in %) in Rwanda?
Your answer should be compact. -80.04. In the year 2008, what is the difference between the ODA received (in %) in Congo (Republic) and ODA received (in %) in Moldova?
Offer a very short reply. 9.79. In the year 2008, what is the difference between the ODA received (in %) in Congo (Republic) and ODA received (in %) in Rwanda?
Offer a terse response. -58.17. In the year 2008, what is the difference between the ODA received (in %) of Moldova and ODA received (in %) of Rwanda?
Ensure brevity in your answer.  -67.97. In the year 2009, what is the difference between the ODA received (in %) of Belarus and ODA received (in %) of Congo (Republic)?
Your answer should be compact. -12.58. In the year 2009, what is the difference between the ODA received (in %) of Belarus and ODA received (in %) of Moldova?
Your response must be concise. -18.82. In the year 2009, what is the difference between the ODA received (in %) of Belarus and ODA received (in %) of Rwanda?
Give a very brief answer. -73.88. In the year 2009, what is the difference between the ODA received (in %) of Congo (Republic) and ODA received (in %) of Moldova?
Keep it short and to the point. -6.24. In the year 2009, what is the difference between the ODA received (in %) in Congo (Republic) and ODA received (in %) in Rwanda?
Offer a terse response. -61.29. In the year 2009, what is the difference between the ODA received (in %) of Moldova and ODA received (in %) of Rwanda?
Your response must be concise. -55.05. In the year 2010, what is the difference between the ODA received (in %) in Belarus and ODA received (in %) in Congo (Republic)?
Your response must be concise. -52.61. In the year 2010, what is the difference between the ODA received (in %) in Belarus and ODA received (in %) in Moldova?
Your answer should be very brief. -33.8. In the year 2010, what is the difference between the ODA received (in %) of Belarus and ODA received (in %) of Rwanda?
Give a very brief answer. -77.46. In the year 2010, what is the difference between the ODA received (in %) of Congo (Republic) and ODA received (in %) of Moldova?
Offer a very short reply. 18.81. In the year 2010, what is the difference between the ODA received (in %) of Congo (Republic) and ODA received (in %) of Rwanda?
Give a very brief answer. -24.85. In the year 2010, what is the difference between the ODA received (in %) of Moldova and ODA received (in %) of Rwanda?
Make the answer very short. -43.66. In the year 2011, what is the difference between the ODA received (in %) in Belarus and ODA received (in %) in Congo (Republic)?
Keep it short and to the point. -6.57. In the year 2011, what is the difference between the ODA received (in %) of Belarus and ODA received (in %) of Moldova?
Provide a succinct answer. -26.81. In the year 2011, what is the difference between the ODA received (in %) in Belarus and ODA received (in %) in Rwanda?
Keep it short and to the point. -83.28. In the year 2011, what is the difference between the ODA received (in %) of Congo (Republic) and ODA received (in %) of Moldova?
Your answer should be compact. -20.24. In the year 2011, what is the difference between the ODA received (in %) of Congo (Republic) and ODA received (in %) of Rwanda?
Your answer should be compact. -76.72. In the year 2011, what is the difference between the ODA received (in %) of Moldova and ODA received (in %) of Rwanda?
Your response must be concise. -56.47. In the year 2012, what is the difference between the ODA received (in %) of Belarus and ODA received (in %) of Congo (Republic)?
Your answer should be very brief. -3.44. In the year 2012, what is the difference between the ODA received (in %) of Belarus and ODA received (in %) of Moldova?
Your response must be concise. -27.01. In the year 2012, what is the difference between the ODA received (in %) of Belarus and ODA received (in %) of Rwanda?
Your answer should be compact. -46.58. In the year 2012, what is the difference between the ODA received (in %) of Congo (Republic) and ODA received (in %) of Moldova?
Your answer should be compact. -23.57. In the year 2012, what is the difference between the ODA received (in %) in Congo (Republic) and ODA received (in %) in Rwanda?
Keep it short and to the point. -43.14. In the year 2012, what is the difference between the ODA received (in %) of Moldova and ODA received (in %) of Rwanda?
Make the answer very short. -19.57. In the year 2013, what is the difference between the ODA received (in %) of Belarus and ODA received (in %) of Congo (Republic)?
Make the answer very short. -3.09. In the year 2013, what is the difference between the ODA received (in %) of Belarus and ODA received (in %) of Moldova?
Offer a terse response. -18.65. In the year 2013, what is the difference between the ODA received (in %) in Belarus and ODA received (in %) in Rwanda?
Provide a succinct answer. -53.83. In the year 2013, what is the difference between the ODA received (in %) of Congo (Republic) and ODA received (in %) of Moldova?
Provide a succinct answer. -15.56. In the year 2013, what is the difference between the ODA received (in %) in Congo (Republic) and ODA received (in %) in Rwanda?
Provide a succinct answer. -50.74. In the year 2013, what is the difference between the ODA received (in %) of Moldova and ODA received (in %) of Rwanda?
Offer a terse response. -35.18. What is the ratio of the ODA received (in %) in Belarus in 2006 to that in 2007?
Offer a terse response. 1.19. What is the ratio of the ODA received (in %) of Congo (Republic) in 2006 to that in 2007?
Ensure brevity in your answer.  2.38. What is the ratio of the ODA received (in %) in Moldova in 2006 to that in 2007?
Ensure brevity in your answer.  1.3. What is the ratio of the ODA received (in %) of Rwanda in 2006 to that in 2007?
Offer a very short reply. 1.15. What is the ratio of the ODA received (in %) in Belarus in 2006 to that in 2008?
Ensure brevity in your answer.  1.33. What is the ratio of the ODA received (in %) of Congo (Republic) in 2006 to that in 2008?
Offer a very short reply. 0.69. What is the ratio of the ODA received (in %) in Moldova in 2006 to that in 2008?
Provide a short and direct response. 1.64. What is the ratio of the ODA received (in %) of Rwanda in 2006 to that in 2008?
Your response must be concise. 1.44. What is the ratio of the ODA received (in %) in Belarus in 2006 to that in 2009?
Offer a terse response. 1.21. What is the ratio of the ODA received (in %) in Congo (Republic) in 2006 to that in 2009?
Offer a very short reply. 1.18. What is the ratio of the ODA received (in %) in Moldova in 2006 to that in 2009?
Your answer should be compact. 1.06. What is the ratio of the ODA received (in %) of Rwanda in 2006 to that in 2009?
Give a very brief answer. 1.56. What is the ratio of the ODA received (in %) of Belarus in 2006 to that in 2010?
Ensure brevity in your answer.  1.06. What is the ratio of the ODA received (in %) of Congo (Republic) in 2006 to that in 2010?
Provide a short and direct response. 0.29. What is the ratio of the ODA received (in %) in Moldova in 2006 to that in 2010?
Your answer should be compact. 0.6. What is the ratio of the ODA received (in %) of Rwanda in 2006 to that in 2010?
Make the answer very short. 1.49. What is the ratio of the ODA received (in %) of Belarus in 2006 to that in 2011?
Offer a terse response. 1.15. What is the ratio of the ODA received (in %) in Congo (Republic) in 2006 to that in 2011?
Provide a succinct answer. 2.17. What is the ratio of the ODA received (in %) of Moldova in 2006 to that in 2011?
Your answer should be compact. 0.75. What is the ratio of the ODA received (in %) of Rwanda in 2006 to that in 2011?
Provide a succinct answer. 1.39. What is the ratio of the ODA received (in %) in Belarus in 2006 to that in 2012?
Give a very brief answer. 1.4. What is the ratio of the ODA received (in %) in Congo (Republic) in 2006 to that in 2012?
Give a very brief answer. 3.96. What is the ratio of the ODA received (in %) in Moldova in 2006 to that in 2012?
Provide a short and direct response. 0.75. What is the ratio of the ODA received (in %) of Rwanda in 2006 to that in 2012?
Ensure brevity in your answer.  2.47. What is the ratio of the ODA received (in %) of Belarus in 2006 to that in 2013?
Give a very brief answer. 1.77. What is the ratio of the ODA received (in %) of Congo (Republic) in 2006 to that in 2013?
Give a very brief answer. 4.48. What is the ratio of the ODA received (in %) in Moldova in 2006 to that in 2013?
Offer a terse response. 1.08. What is the ratio of the ODA received (in %) of Rwanda in 2006 to that in 2013?
Your answer should be compact. 2.15. What is the ratio of the ODA received (in %) of Belarus in 2007 to that in 2008?
Make the answer very short. 1.12. What is the ratio of the ODA received (in %) in Congo (Republic) in 2007 to that in 2008?
Offer a very short reply. 0.29. What is the ratio of the ODA received (in %) of Moldova in 2007 to that in 2008?
Offer a very short reply. 1.26. What is the ratio of the ODA received (in %) in Rwanda in 2007 to that in 2008?
Ensure brevity in your answer.  1.26. What is the ratio of the ODA received (in %) in Belarus in 2007 to that in 2009?
Offer a terse response. 1.02. What is the ratio of the ODA received (in %) of Congo (Republic) in 2007 to that in 2009?
Provide a short and direct response. 0.49. What is the ratio of the ODA received (in %) of Moldova in 2007 to that in 2009?
Offer a very short reply. 0.82. What is the ratio of the ODA received (in %) of Rwanda in 2007 to that in 2009?
Offer a very short reply. 1.36. What is the ratio of the ODA received (in %) in Belarus in 2007 to that in 2010?
Keep it short and to the point. 0.89. What is the ratio of the ODA received (in %) of Congo (Republic) in 2007 to that in 2010?
Give a very brief answer. 0.12. What is the ratio of the ODA received (in %) in Moldova in 2007 to that in 2010?
Keep it short and to the point. 0.46. What is the ratio of the ODA received (in %) of Rwanda in 2007 to that in 2010?
Make the answer very short. 1.29. What is the ratio of the ODA received (in %) in Belarus in 2007 to that in 2011?
Keep it short and to the point. 0.97. What is the ratio of the ODA received (in %) of Congo (Republic) in 2007 to that in 2011?
Your answer should be very brief. 0.91. What is the ratio of the ODA received (in %) of Moldova in 2007 to that in 2011?
Ensure brevity in your answer.  0.58. What is the ratio of the ODA received (in %) of Rwanda in 2007 to that in 2011?
Ensure brevity in your answer.  1.21. What is the ratio of the ODA received (in %) of Belarus in 2007 to that in 2012?
Provide a succinct answer. 1.18. What is the ratio of the ODA received (in %) of Congo (Republic) in 2007 to that in 2012?
Offer a very short reply. 1.66. What is the ratio of the ODA received (in %) of Moldova in 2007 to that in 2012?
Offer a very short reply. 0.58. What is the ratio of the ODA received (in %) in Rwanda in 2007 to that in 2012?
Your response must be concise. 2.15. What is the ratio of the ODA received (in %) of Belarus in 2007 to that in 2013?
Provide a short and direct response. 1.49. What is the ratio of the ODA received (in %) of Congo (Republic) in 2007 to that in 2013?
Your answer should be very brief. 1.88. What is the ratio of the ODA received (in %) of Moldova in 2007 to that in 2013?
Provide a short and direct response. 0.83. What is the ratio of the ODA received (in %) of Rwanda in 2007 to that in 2013?
Give a very brief answer. 1.87. What is the ratio of the ODA received (in %) in Belarus in 2008 to that in 2009?
Offer a terse response. 0.91. What is the ratio of the ODA received (in %) of Congo (Republic) in 2008 to that in 2009?
Keep it short and to the point. 1.7. What is the ratio of the ODA received (in %) in Moldova in 2008 to that in 2009?
Offer a very short reply. 0.65. What is the ratio of the ODA received (in %) of Rwanda in 2008 to that in 2009?
Keep it short and to the point. 1.08. What is the ratio of the ODA received (in %) in Belarus in 2008 to that in 2010?
Keep it short and to the point. 0.8. What is the ratio of the ODA received (in %) of Congo (Republic) in 2008 to that in 2010?
Make the answer very short. 0.42. What is the ratio of the ODA received (in %) of Moldova in 2008 to that in 2010?
Ensure brevity in your answer.  0.36. What is the ratio of the ODA received (in %) of Rwanda in 2008 to that in 2010?
Give a very brief answer. 1.03. What is the ratio of the ODA received (in %) in Belarus in 2008 to that in 2011?
Give a very brief answer. 0.86. What is the ratio of the ODA received (in %) of Congo (Republic) in 2008 to that in 2011?
Keep it short and to the point. 3.14. What is the ratio of the ODA received (in %) in Moldova in 2008 to that in 2011?
Ensure brevity in your answer.  0.46. What is the ratio of the ODA received (in %) of Rwanda in 2008 to that in 2011?
Your answer should be compact. 0.96. What is the ratio of the ODA received (in %) in Belarus in 2008 to that in 2012?
Give a very brief answer. 1.05. What is the ratio of the ODA received (in %) of Congo (Republic) in 2008 to that in 2012?
Your answer should be very brief. 5.73. What is the ratio of the ODA received (in %) in Moldova in 2008 to that in 2012?
Ensure brevity in your answer.  0.46. What is the ratio of the ODA received (in %) of Rwanda in 2008 to that in 2012?
Give a very brief answer. 1.71. What is the ratio of the ODA received (in %) in Belarus in 2008 to that in 2013?
Make the answer very short. 1.33. What is the ratio of the ODA received (in %) in Congo (Republic) in 2008 to that in 2013?
Your answer should be very brief. 6.47. What is the ratio of the ODA received (in %) in Moldova in 2008 to that in 2013?
Provide a succinct answer. 0.66. What is the ratio of the ODA received (in %) of Rwanda in 2008 to that in 2013?
Ensure brevity in your answer.  1.49. What is the ratio of the ODA received (in %) of Belarus in 2009 to that in 2010?
Provide a short and direct response. 0.88. What is the ratio of the ODA received (in %) in Congo (Republic) in 2009 to that in 2010?
Your answer should be compact. 0.25. What is the ratio of the ODA received (in %) of Moldova in 2009 to that in 2010?
Give a very brief answer. 0.56. What is the ratio of the ODA received (in %) of Rwanda in 2009 to that in 2010?
Your answer should be compact. 0.95. What is the ratio of the ODA received (in %) in Belarus in 2009 to that in 2011?
Offer a very short reply. 0.95. What is the ratio of the ODA received (in %) of Congo (Republic) in 2009 to that in 2011?
Ensure brevity in your answer.  1.84. What is the ratio of the ODA received (in %) of Moldova in 2009 to that in 2011?
Your answer should be compact. 0.71. What is the ratio of the ODA received (in %) in Rwanda in 2009 to that in 2011?
Ensure brevity in your answer.  0.89. What is the ratio of the ODA received (in %) in Belarus in 2009 to that in 2012?
Offer a terse response. 1.16. What is the ratio of the ODA received (in %) in Congo (Republic) in 2009 to that in 2012?
Ensure brevity in your answer.  3.36. What is the ratio of the ODA received (in %) of Moldova in 2009 to that in 2012?
Your answer should be very brief. 0.7. What is the ratio of the ODA received (in %) in Rwanda in 2009 to that in 2012?
Provide a short and direct response. 1.58. What is the ratio of the ODA received (in %) in Belarus in 2009 to that in 2013?
Ensure brevity in your answer.  1.46. What is the ratio of the ODA received (in %) in Congo (Republic) in 2009 to that in 2013?
Offer a very short reply. 3.8. What is the ratio of the ODA received (in %) in Moldova in 2009 to that in 2013?
Make the answer very short. 1.02. What is the ratio of the ODA received (in %) of Rwanda in 2009 to that in 2013?
Give a very brief answer. 1.37. What is the ratio of the ODA received (in %) in Belarus in 2010 to that in 2011?
Offer a terse response. 1.08. What is the ratio of the ODA received (in %) of Congo (Republic) in 2010 to that in 2011?
Your answer should be very brief. 7.47. What is the ratio of the ODA received (in %) of Moldova in 2010 to that in 2011?
Provide a succinct answer. 1.26. What is the ratio of the ODA received (in %) of Rwanda in 2010 to that in 2011?
Keep it short and to the point. 0.93. What is the ratio of the ODA received (in %) of Belarus in 2010 to that in 2012?
Ensure brevity in your answer.  1.32. What is the ratio of the ODA received (in %) in Congo (Republic) in 2010 to that in 2012?
Provide a succinct answer. 13.65. What is the ratio of the ODA received (in %) in Moldova in 2010 to that in 2012?
Offer a very short reply. 1.25. What is the ratio of the ODA received (in %) in Rwanda in 2010 to that in 2012?
Provide a short and direct response. 1.66. What is the ratio of the ODA received (in %) in Belarus in 2010 to that in 2013?
Provide a succinct answer. 1.66. What is the ratio of the ODA received (in %) in Congo (Republic) in 2010 to that in 2013?
Offer a terse response. 15.42. What is the ratio of the ODA received (in %) of Moldova in 2010 to that in 2013?
Your answer should be compact. 1.81. What is the ratio of the ODA received (in %) in Rwanda in 2010 to that in 2013?
Keep it short and to the point. 1.44. What is the ratio of the ODA received (in %) of Belarus in 2011 to that in 2012?
Your answer should be compact. 1.22. What is the ratio of the ODA received (in %) of Congo (Republic) in 2011 to that in 2012?
Provide a succinct answer. 1.83. What is the ratio of the ODA received (in %) of Rwanda in 2011 to that in 2012?
Ensure brevity in your answer.  1.78. What is the ratio of the ODA received (in %) of Belarus in 2011 to that in 2013?
Your answer should be compact. 1.54. What is the ratio of the ODA received (in %) in Congo (Republic) in 2011 to that in 2013?
Your response must be concise. 2.06. What is the ratio of the ODA received (in %) in Moldova in 2011 to that in 2013?
Offer a terse response. 1.44. What is the ratio of the ODA received (in %) in Rwanda in 2011 to that in 2013?
Your answer should be compact. 1.55. What is the ratio of the ODA received (in %) of Belarus in 2012 to that in 2013?
Offer a very short reply. 1.26. What is the ratio of the ODA received (in %) in Congo (Republic) in 2012 to that in 2013?
Your answer should be very brief. 1.13. What is the ratio of the ODA received (in %) of Moldova in 2012 to that in 2013?
Give a very brief answer. 1.44. What is the ratio of the ODA received (in %) of Rwanda in 2012 to that in 2013?
Your answer should be very brief. 0.87. What is the difference between the highest and the second highest ODA received (in %) of Belarus?
Offer a very short reply. 0.04. What is the difference between the highest and the second highest ODA received (in %) of Congo (Republic)?
Provide a succinct answer. 30.87. What is the difference between the highest and the second highest ODA received (in %) of Moldova?
Your answer should be compact. 6.94. What is the difference between the highest and the second highest ODA received (in %) of Rwanda?
Ensure brevity in your answer.  15.26. What is the difference between the highest and the lowest ODA received (in %) in Belarus?
Your response must be concise. 0.28. What is the difference between the highest and the lowest ODA received (in %) in Congo (Republic)?
Offer a very short reply. 49.77. What is the difference between the highest and the lowest ODA received (in %) in Moldova?
Offer a terse response. 21.85. What is the difference between the highest and the lowest ODA received (in %) of Rwanda?
Make the answer very short. 69.3. 